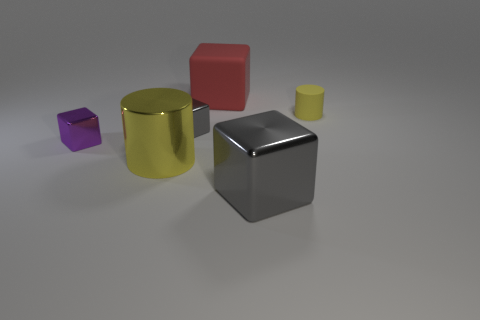Are there any large matte blocks that are on the left side of the small cube left of the yellow cylinder that is in front of the tiny gray object?
Ensure brevity in your answer.  No. There is a big metal block in front of the cube that is behind the tiny object that is right of the large red rubber object; what is its color?
Offer a terse response. Gray. There is a big gray object that is the same shape as the red rubber thing; what material is it?
Make the answer very short. Metal. There is a yellow cylinder that is left of the shiny block that is behind the small purple cube; what size is it?
Provide a short and direct response. Large. There is a yellow cylinder behind the small purple block; what material is it?
Provide a short and direct response. Rubber. There is a yellow cylinder that is made of the same material as the tiny purple block; what size is it?
Give a very brief answer. Large. How many other things are the same shape as the purple metal thing?
Give a very brief answer. 3. There is a red thing; is it the same shape as the yellow object that is in front of the small gray block?
Make the answer very short. No. There is a object that is the same color as the small rubber cylinder; what is its shape?
Offer a very short reply. Cylinder. Is there a yellow object made of the same material as the tiny yellow cylinder?
Offer a terse response. No. 